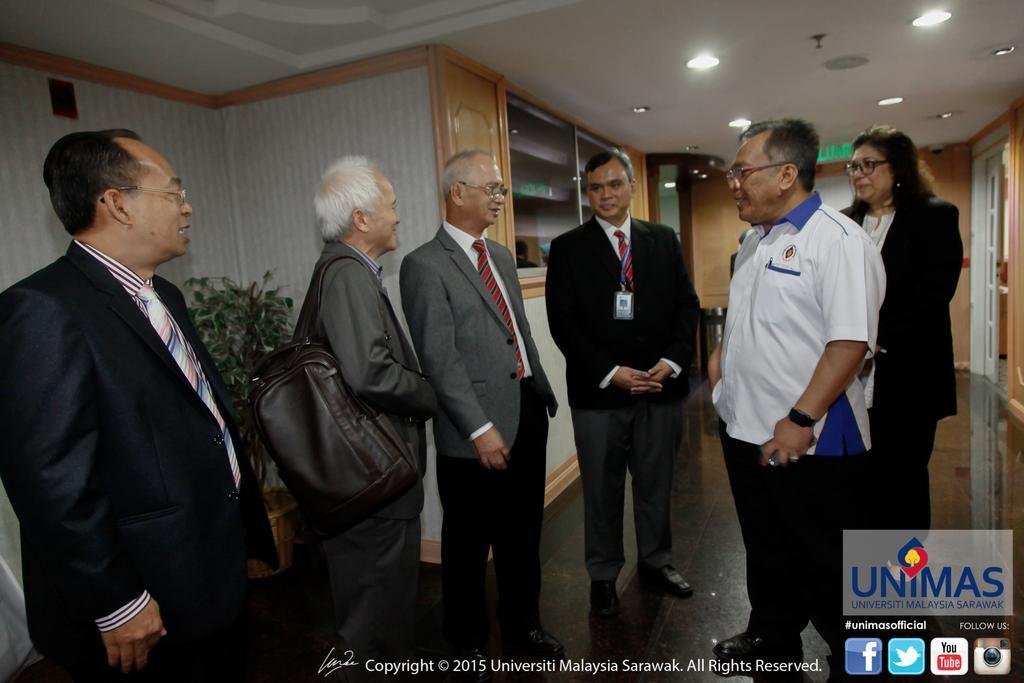Please provide a concise description of this image. This image is taken indoors. At the bottom of the image there is a floor. In the background there are a few walls with doors and there are a few cupboards. At the top of the image there is a ceiling with a few lights. On the left side of the image a man is standing on the floor and there is a plant in the pot. In the middle of the image four men and a woman are standing on the floor and they are with smiling faces. On the right side of the image there are a few logs and there is a text on the image. 